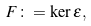Convert formula to latex. <formula><loc_0><loc_0><loc_500><loc_500>F \colon = \ker \varepsilon ,</formula> 